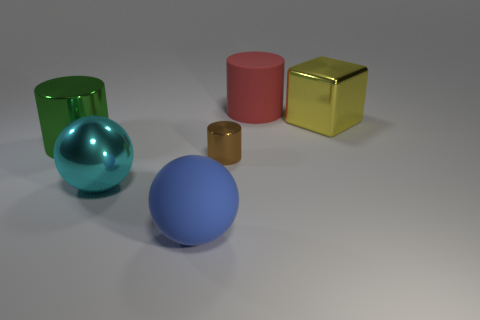There is a brown cylinder that is made of the same material as the yellow object; what is its size?
Offer a terse response. Small. What is the material of the red thing that is the same size as the cyan metal object?
Make the answer very short. Rubber. How many shiny cylinders are right of the large cylinder that is in front of the large thing behind the big yellow thing?
Your response must be concise. 1. The large thing that is both in front of the big rubber cylinder and behind the green metallic thing is what color?
Keep it short and to the point. Yellow. How many red cylinders are the same size as the green cylinder?
Your answer should be very brief. 1. What shape is the large matte object behind the large cylinder that is in front of the shiny cube?
Your response must be concise. Cylinder. What shape is the big rubber thing behind the thing that is left of the big cyan shiny object that is left of the big blue ball?
Your answer should be compact. Cylinder. What number of brown objects are the same shape as the green metal object?
Your answer should be compact. 1. There is a matte object behind the cyan metal sphere; what number of large objects are in front of it?
Your answer should be compact. 4. How many rubber things are either red cylinders or yellow cubes?
Provide a succinct answer. 1. 